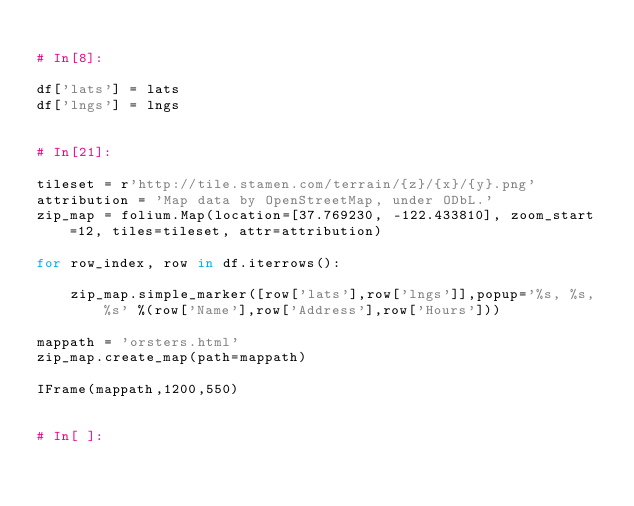<code> <loc_0><loc_0><loc_500><loc_500><_Python_>
# In[8]:

df['lats'] = lats
df['lngs'] = lngs


# In[21]:

tileset = r'http://tile.stamen.com/terrain/{z}/{x}/{y}.png'
attribution = 'Map data by OpenStreetMap, under ODbL.'
zip_map = folium.Map(location=[37.769230, -122.433810], zoom_start=12, tiles=tileset, attr=attribution)

for row_index, row in df.iterrows():
    
    zip_map.simple_marker([row['lats'],row['lngs']],popup='%s, %s, %s' %(row['Name'],row['Address'],row['Hours']))

mappath = 'orsters.html'
zip_map.create_map(path=mappath)

IFrame(mappath,1200,550)


# In[ ]:



</code> 